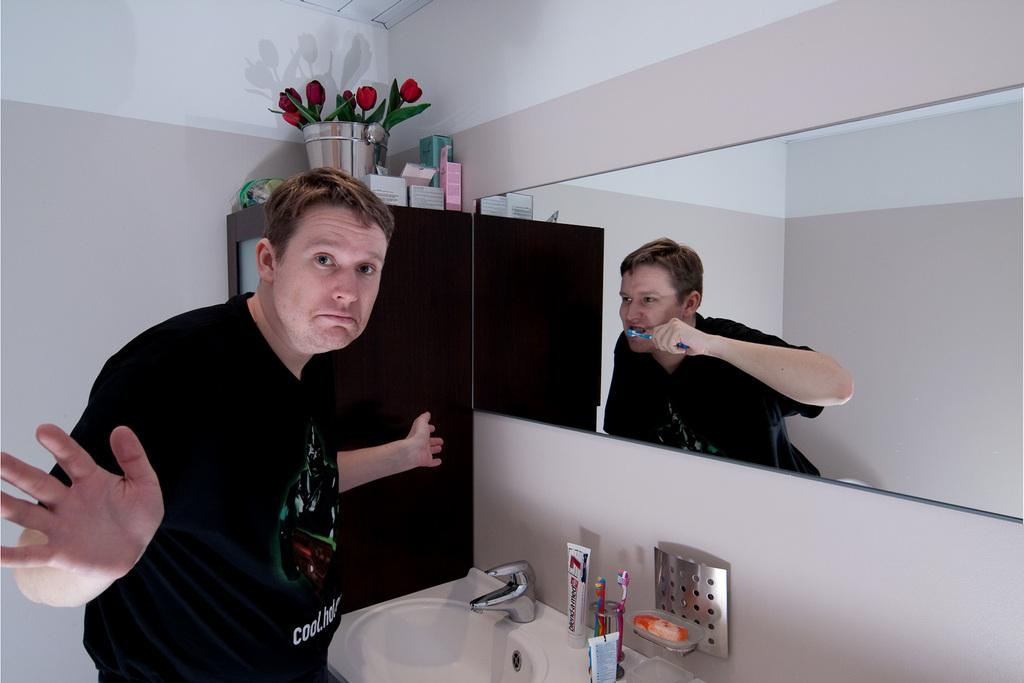<image>
Create a compact narrative representing the image presented. A man in the bathroom a toothpaste of number 7 